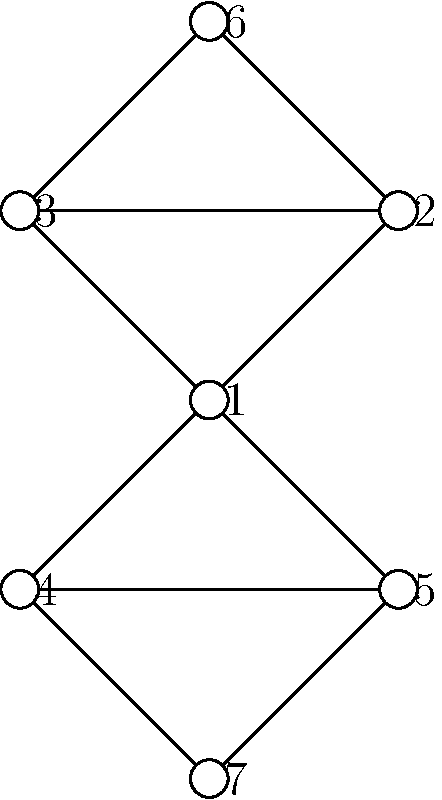In the given criminal network diagram, which node has the highest degree centrality, potentially indicating a key player in the organization? To determine the node with the highest degree centrality, we need to count the number of direct connections (edges) each node has:

1. Count connections for each node:
   Node 1: 4 connections
   Node 2: 3 connections
   Node 3: 3 connections
   Node 4: 3 connections
   Node 5: 3 connections
   Node 6: 2 connections
   Node 7: 2 connections

2. Identify the highest count:
   The highest count is 4, corresponding to Node 1.

3. Interpret the result:
   Node 1 has the highest degree centrality, which suggests it may be a central figure in the criminal network, potentially acting as a hub or coordinator.

This analysis helps identify key players in criminal organizations by revealing which individuals have the most direct connections, indicating their potential influence or importance within the network.
Answer: Node 1 